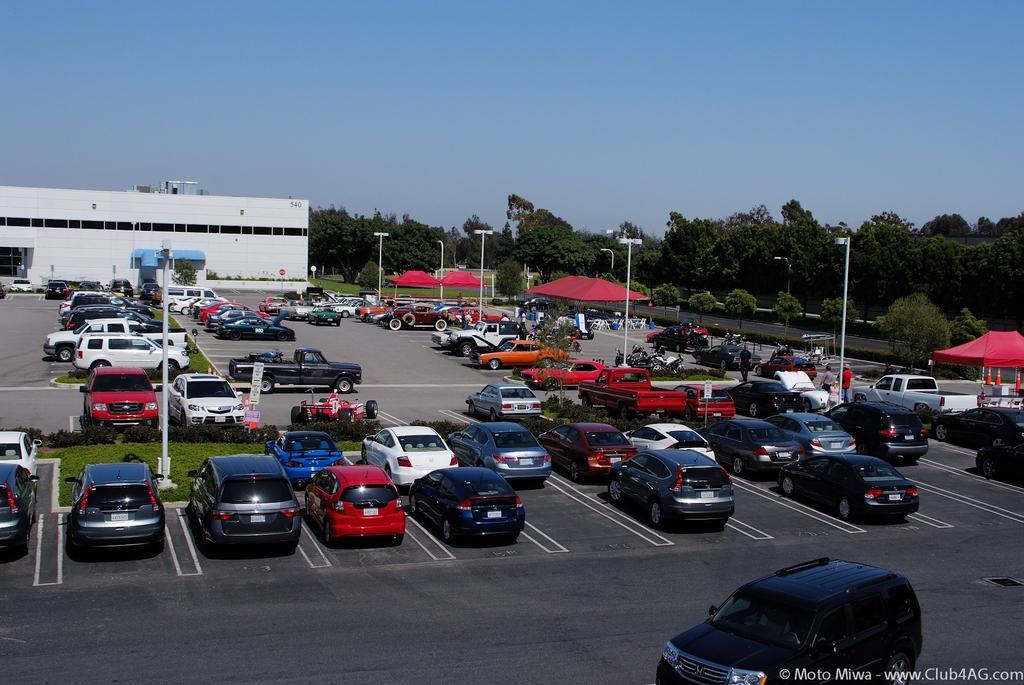How would you summarize this image in a sentence or two? In this image I can see few vehicles in different colors. I can see few trees,poles,signboards,traffic cones and a shed. The sky is in blue color. 